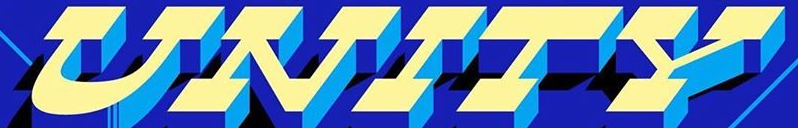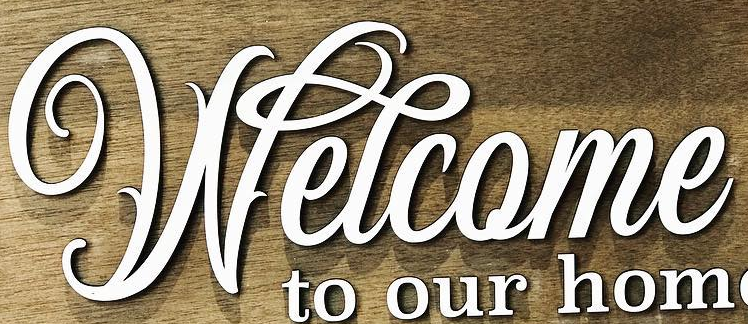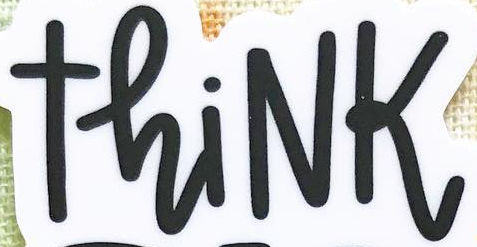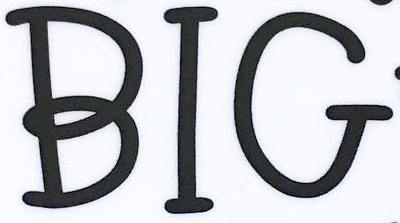What text is displayed in these images sequentially, separated by a semicolon? UNITY; Welcome; ThiNK; BIG 